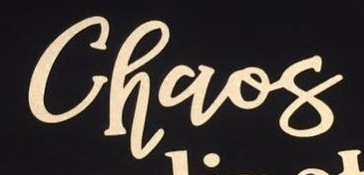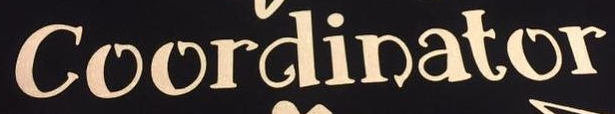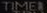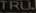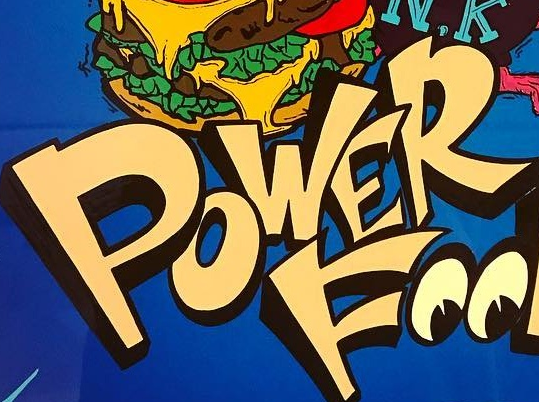Read the text from these images in sequence, separated by a semicolon. Chaos; Coordinator; TIMEI; TRU; POWER 